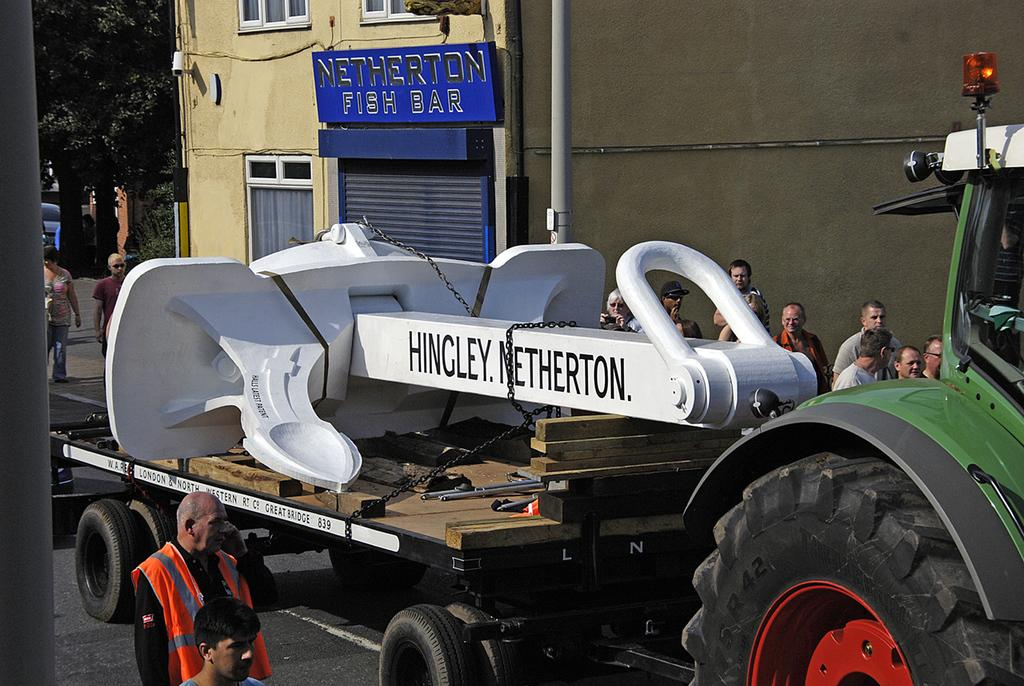What is on the road in the image? There is a vehicle on the road in the image. What are the people near the vehicle doing? People are standing near the vehicle in the image. What type of vegetation can be seen in the image? There is a tree in the image. What type of structure is visible in the image? There is a building in the image. What type of bread is being cooked by the rat in the image? There is no bread or rat present in the image. 